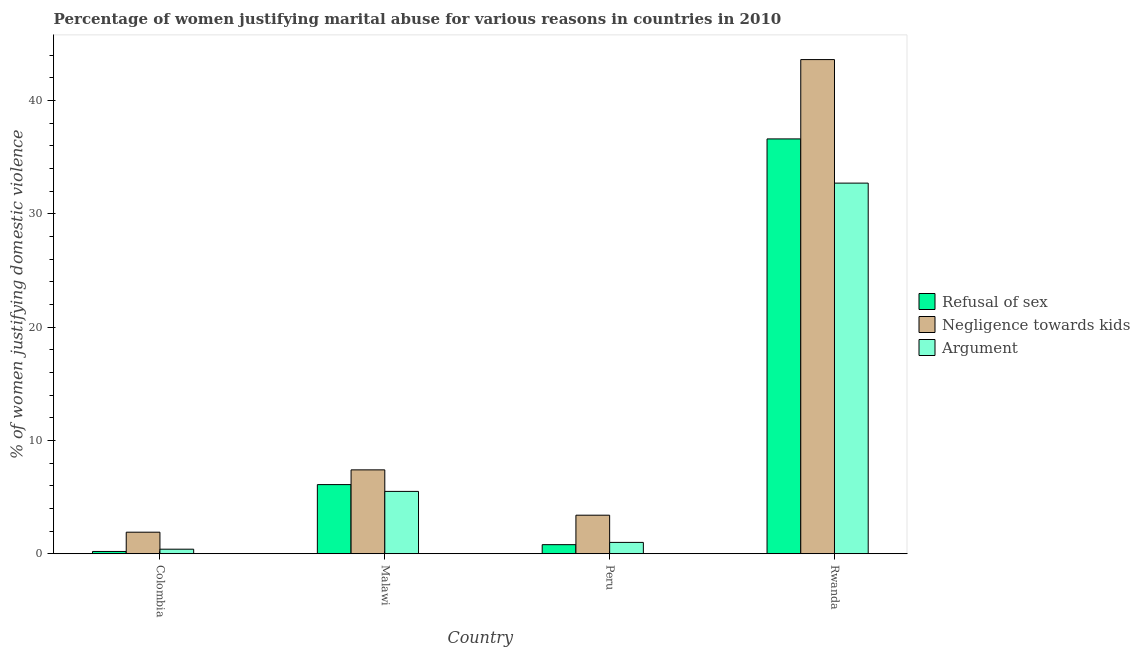How many different coloured bars are there?
Your response must be concise. 3. Are the number of bars per tick equal to the number of legend labels?
Offer a very short reply. Yes. What is the label of the 3rd group of bars from the left?
Ensure brevity in your answer.  Peru. In how many cases, is the number of bars for a given country not equal to the number of legend labels?
Your answer should be very brief. 0. Across all countries, what is the maximum percentage of women justifying domestic violence due to negligence towards kids?
Your answer should be compact. 43.6. In which country was the percentage of women justifying domestic violence due to arguments maximum?
Ensure brevity in your answer.  Rwanda. In which country was the percentage of women justifying domestic violence due to negligence towards kids minimum?
Provide a succinct answer. Colombia. What is the total percentage of women justifying domestic violence due to arguments in the graph?
Your answer should be compact. 39.6. What is the difference between the percentage of women justifying domestic violence due to arguments in Malawi and that in Rwanda?
Provide a succinct answer. -27.2. What is the average percentage of women justifying domestic violence due to refusal of sex per country?
Your answer should be very brief. 10.93. What is the ratio of the percentage of women justifying domestic violence due to refusal of sex in Malawi to that in Rwanda?
Give a very brief answer. 0.17. Is the percentage of women justifying domestic violence due to refusal of sex in Malawi less than that in Peru?
Your answer should be very brief. No. What is the difference between the highest and the second highest percentage of women justifying domestic violence due to arguments?
Ensure brevity in your answer.  27.2. What is the difference between the highest and the lowest percentage of women justifying domestic violence due to refusal of sex?
Provide a short and direct response. 36.4. Is the sum of the percentage of women justifying domestic violence due to negligence towards kids in Malawi and Rwanda greater than the maximum percentage of women justifying domestic violence due to arguments across all countries?
Your response must be concise. Yes. What does the 2nd bar from the left in Peru represents?
Give a very brief answer. Negligence towards kids. What does the 2nd bar from the right in Colombia represents?
Your answer should be very brief. Negligence towards kids. Are the values on the major ticks of Y-axis written in scientific E-notation?
Provide a short and direct response. No. Does the graph contain grids?
Your answer should be compact. No. Where does the legend appear in the graph?
Your response must be concise. Center right. What is the title of the graph?
Offer a very short reply. Percentage of women justifying marital abuse for various reasons in countries in 2010. What is the label or title of the Y-axis?
Offer a terse response. % of women justifying domestic violence. What is the % of women justifying domestic violence in Negligence towards kids in Colombia?
Make the answer very short. 1.9. What is the % of women justifying domestic violence in Argument in Colombia?
Give a very brief answer. 0.4. What is the % of women justifying domestic violence of Refusal of sex in Malawi?
Your answer should be very brief. 6.1. What is the % of women justifying domestic violence in Negligence towards kids in Malawi?
Your answer should be very brief. 7.4. What is the % of women justifying domestic violence in Refusal of sex in Peru?
Give a very brief answer. 0.8. What is the % of women justifying domestic violence in Refusal of sex in Rwanda?
Ensure brevity in your answer.  36.6. What is the % of women justifying domestic violence in Negligence towards kids in Rwanda?
Ensure brevity in your answer.  43.6. What is the % of women justifying domestic violence in Argument in Rwanda?
Your answer should be very brief. 32.7. Across all countries, what is the maximum % of women justifying domestic violence of Refusal of sex?
Offer a very short reply. 36.6. Across all countries, what is the maximum % of women justifying domestic violence in Negligence towards kids?
Ensure brevity in your answer.  43.6. Across all countries, what is the maximum % of women justifying domestic violence in Argument?
Your response must be concise. 32.7. Across all countries, what is the minimum % of women justifying domestic violence of Argument?
Keep it short and to the point. 0.4. What is the total % of women justifying domestic violence in Refusal of sex in the graph?
Give a very brief answer. 43.7. What is the total % of women justifying domestic violence in Negligence towards kids in the graph?
Provide a succinct answer. 56.3. What is the total % of women justifying domestic violence of Argument in the graph?
Make the answer very short. 39.6. What is the difference between the % of women justifying domestic violence in Negligence towards kids in Colombia and that in Malawi?
Provide a short and direct response. -5.5. What is the difference between the % of women justifying domestic violence of Refusal of sex in Colombia and that in Peru?
Give a very brief answer. -0.6. What is the difference between the % of women justifying domestic violence of Argument in Colombia and that in Peru?
Give a very brief answer. -0.6. What is the difference between the % of women justifying domestic violence in Refusal of sex in Colombia and that in Rwanda?
Give a very brief answer. -36.4. What is the difference between the % of women justifying domestic violence of Negligence towards kids in Colombia and that in Rwanda?
Your answer should be very brief. -41.7. What is the difference between the % of women justifying domestic violence of Argument in Colombia and that in Rwanda?
Make the answer very short. -32.3. What is the difference between the % of women justifying domestic violence in Negligence towards kids in Malawi and that in Peru?
Your answer should be compact. 4. What is the difference between the % of women justifying domestic violence of Refusal of sex in Malawi and that in Rwanda?
Your answer should be compact. -30.5. What is the difference between the % of women justifying domestic violence of Negligence towards kids in Malawi and that in Rwanda?
Your response must be concise. -36.2. What is the difference between the % of women justifying domestic violence in Argument in Malawi and that in Rwanda?
Your answer should be very brief. -27.2. What is the difference between the % of women justifying domestic violence in Refusal of sex in Peru and that in Rwanda?
Make the answer very short. -35.8. What is the difference between the % of women justifying domestic violence in Negligence towards kids in Peru and that in Rwanda?
Provide a short and direct response. -40.2. What is the difference between the % of women justifying domestic violence in Argument in Peru and that in Rwanda?
Offer a terse response. -31.7. What is the difference between the % of women justifying domestic violence in Refusal of sex in Colombia and the % of women justifying domestic violence in Negligence towards kids in Malawi?
Provide a succinct answer. -7.2. What is the difference between the % of women justifying domestic violence of Refusal of sex in Colombia and the % of women justifying domestic violence of Argument in Malawi?
Your response must be concise. -5.3. What is the difference between the % of women justifying domestic violence in Refusal of sex in Colombia and the % of women justifying domestic violence in Negligence towards kids in Peru?
Provide a short and direct response. -3.2. What is the difference between the % of women justifying domestic violence in Refusal of sex in Colombia and the % of women justifying domestic violence in Argument in Peru?
Provide a short and direct response. -0.8. What is the difference between the % of women justifying domestic violence in Negligence towards kids in Colombia and the % of women justifying domestic violence in Argument in Peru?
Ensure brevity in your answer.  0.9. What is the difference between the % of women justifying domestic violence in Refusal of sex in Colombia and the % of women justifying domestic violence in Negligence towards kids in Rwanda?
Offer a very short reply. -43.4. What is the difference between the % of women justifying domestic violence of Refusal of sex in Colombia and the % of women justifying domestic violence of Argument in Rwanda?
Provide a short and direct response. -32.5. What is the difference between the % of women justifying domestic violence of Negligence towards kids in Colombia and the % of women justifying domestic violence of Argument in Rwanda?
Provide a short and direct response. -30.8. What is the difference between the % of women justifying domestic violence of Refusal of sex in Malawi and the % of women justifying domestic violence of Argument in Peru?
Provide a short and direct response. 5.1. What is the difference between the % of women justifying domestic violence of Negligence towards kids in Malawi and the % of women justifying domestic violence of Argument in Peru?
Your response must be concise. 6.4. What is the difference between the % of women justifying domestic violence of Refusal of sex in Malawi and the % of women justifying domestic violence of Negligence towards kids in Rwanda?
Give a very brief answer. -37.5. What is the difference between the % of women justifying domestic violence in Refusal of sex in Malawi and the % of women justifying domestic violence in Argument in Rwanda?
Your answer should be very brief. -26.6. What is the difference between the % of women justifying domestic violence in Negligence towards kids in Malawi and the % of women justifying domestic violence in Argument in Rwanda?
Provide a short and direct response. -25.3. What is the difference between the % of women justifying domestic violence of Refusal of sex in Peru and the % of women justifying domestic violence of Negligence towards kids in Rwanda?
Ensure brevity in your answer.  -42.8. What is the difference between the % of women justifying domestic violence in Refusal of sex in Peru and the % of women justifying domestic violence in Argument in Rwanda?
Give a very brief answer. -31.9. What is the difference between the % of women justifying domestic violence of Negligence towards kids in Peru and the % of women justifying domestic violence of Argument in Rwanda?
Your response must be concise. -29.3. What is the average % of women justifying domestic violence in Refusal of sex per country?
Your response must be concise. 10.93. What is the average % of women justifying domestic violence in Negligence towards kids per country?
Make the answer very short. 14.07. What is the average % of women justifying domestic violence of Argument per country?
Offer a very short reply. 9.9. What is the difference between the % of women justifying domestic violence in Refusal of sex and % of women justifying domestic violence in Negligence towards kids in Colombia?
Your answer should be compact. -1.7. What is the difference between the % of women justifying domestic violence of Negligence towards kids and % of women justifying domestic violence of Argument in Colombia?
Keep it short and to the point. 1.5. What is the difference between the % of women justifying domestic violence in Refusal of sex and % of women justifying domestic violence in Negligence towards kids in Malawi?
Your answer should be compact. -1.3. What is the difference between the % of women justifying domestic violence in Refusal of sex and % of women justifying domestic violence in Argument in Malawi?
Your answer should be very brief. 0.6. What is the difference between the % of women justifying domestic violence of Negligence towards kids and % of women justifying domestic violence of Argument in Malawi?
Your answer should be very brief. 1.9. What is the difference between the % of women justifying domestic violence of Refusal of sex and % of women justifying domestic violence of Negligence towards kids in Peru?
Ensure brevity in your answer.  -2.6. What is the difference between the % of women justifying domestic violence of Negligence towards kids and % of women justifying domestic violence of Argument in Peru?
Make the answer very short. 2.4. What is the difference between the % of women justifying domestic violence in Refusal of sex and % of women justifying domestic violence in Negligence towards kids in Rwanda?
Your answer should be compact. -7. What is the difference between the % of women justifying domestic violence of Refusal of sex and % of women justifying domestic violence of Argument in Rwanda?
Ensure brevity in your answer.  3.9. What is the ratio of the % of women justifying domestic violence in Refusal of sex in Colombia to that in Malawi?
Ensure brevity in your answer.  0.03. What is the ratio of the % of women justifying domestic violence in Negligence towards kids in Colombia to that in Malawi?
Your answer should be compact. 0.26. What is the ratio of the % of women justifying domestic violence of Argument in Colombia to that in Malawi?
Your response must be concise. 0.07. What is the ratio of the % of women justifying domestic violence of Negligence towards kids in Colombia to that in Peru?
Your answer should be compact. 0.56. What is the ratio of the % of women justifying domestic violence of Refusal of sex in Colombia to that in Rwanda?
Give a very brief answer. 0.01. What is the ratio of the % of women justifying domestic violence in Negligence towards kids in Colombia to that in Rwanda?
Provide a short and direct response. 0.04. What is the ratio of the % of women justifying domestic violence of Argument in Colombia to that in Rwanda?
Provide a short and direct response. 0.01. What is the ratio of the % of women justifying domestic violence in Refusal of sex in Malawi to that in Peru?
Offer a terse response. 7.62. What is the ratio of the % of women justifying domestic violence in Negligence towards kids in Malawi to that in Peru?
Your response must be concise. 2.18. What is the ratio of the % of women justifying domestic violence of Refusal of sex in Malawi to that in Rwanda?
Your answer should be compact. 0.17. What is the ratio of the % of women justifying domestic violence in Negligence towards kids in Malawi to that in Rwanda?
Your answer should be very brief. 0.17. What is the ratio of the % of women justifying domestic violence in Argument in Malawi to that in Rwanda?
Your response must be concise. 0.17. What is the ratio of the % of women justifying domestic violence of Refusal of sex in Peru to that in Rwanda?
Provide a short and direct response. 0.02. What is the ratio of the % of women justifying domestic violence of Negligence towards kids in Peru to that in Rwanda?
Provide a succinct answer. 0.08. What is the ratio of the % of women justifying domestic violence in Argument in Peru to that in Rwanda?
Your answer should be very brief. 0.03. What is the difference between the highest and the second highest % of women justifying domestic violence in Refusal of sex?
Give a very brief answer. 30.5. What is the difference between the highest and the second highest % of women justifying domestic violence in Negligence towards kids?
Your answer should be very brief. 36.2. What is the difference between the highest and the second highest % of women justifying domestic violence of Argument?
Offer a terse response. 27.2. What is the difference between the highest and the lowest % of women justifying domestic violence of Refusal of sex?
Ensure brevity in your answer.  36.4. What is the difference between the highest and the lowest % of women justifying domestic violence in Negligence towards kids?
Offer a terse response. 41.7. What is the difference between the highest and the lowest % of women justifying domestic violence of Argument?
Your answer should be compact. 32.3. 